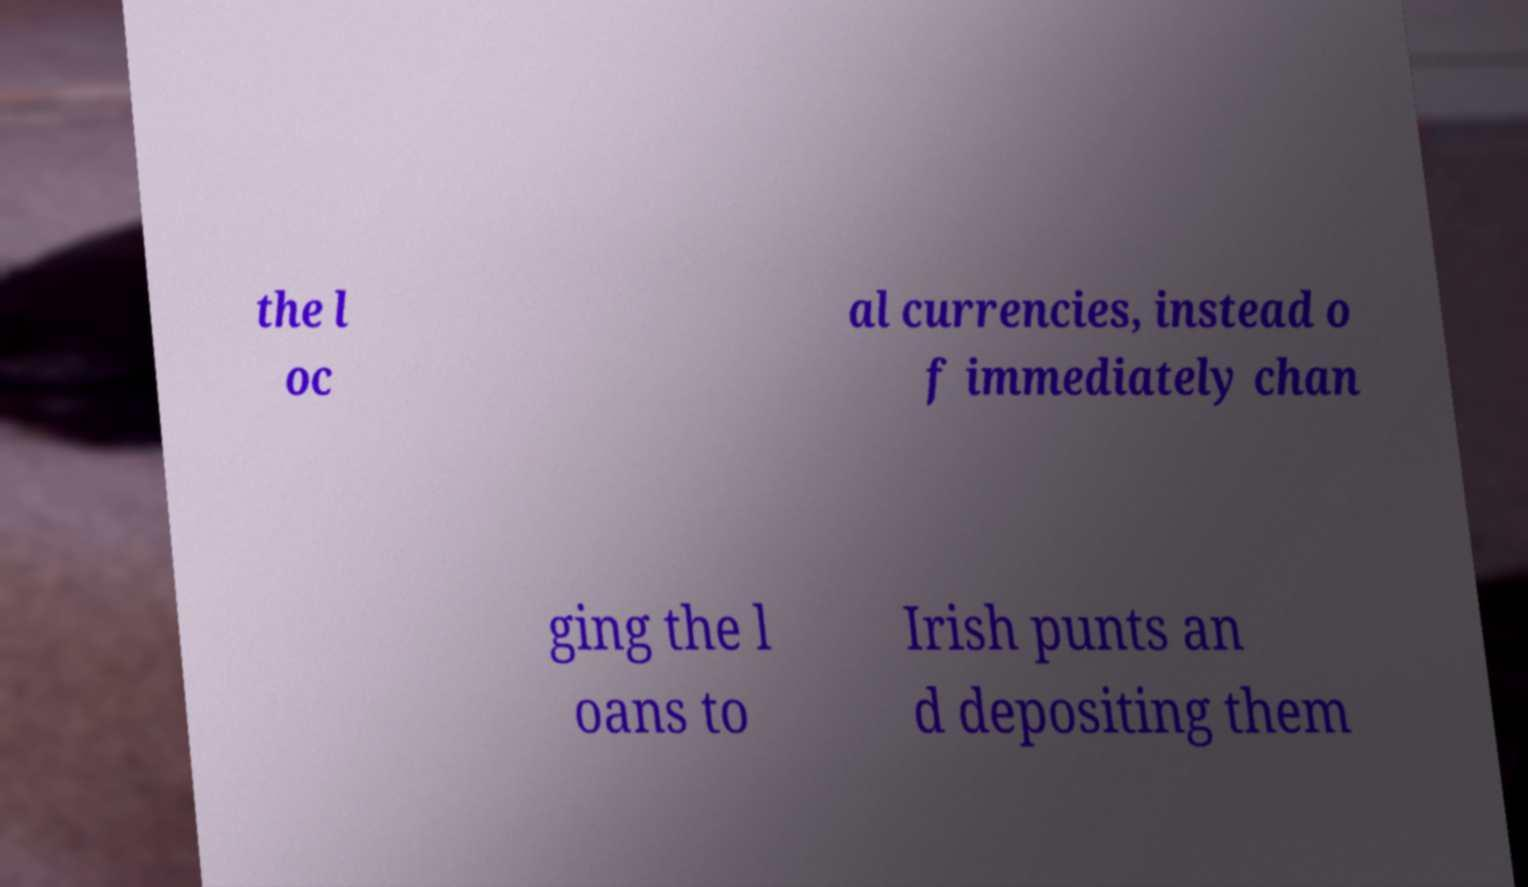Can you read and provide the text displayed in the image?This photo seems to have some interesting text. Can you extract and type it out for me? the l oc al currencies, instead o f immediately chan ging the l oans to Irish punts an d depositing them 